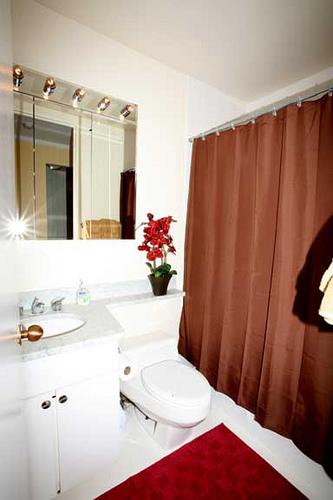What kind of flower is used for the decor?
Give a very brief answer. Lilly. Which room is this?
Short answer required. Bathroom. Has this room been recently cleaned?
Write a very short answer. Yes. Where is the mirror?
Quick response, please. On wall. 